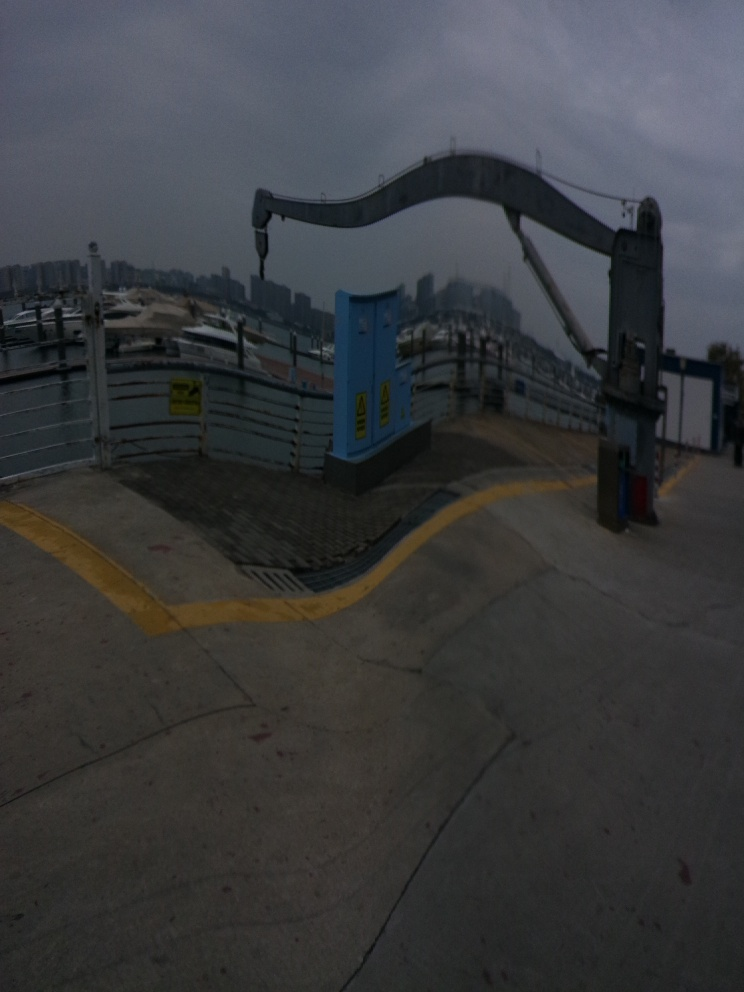What does the environment around the device suggest about its location? The environment includes safety barriers and warning signs, indicating that this is likely an area where specialized operations take place, such as a port, industrial complex, or a construction site. There are no visible cargo or materials being handled at the moment, suggesting that the photo was taken during a pause in activity or outside of working hours. The surrounding cityscape suggests that the location is urban and potentially near a commercial or transport hub. 